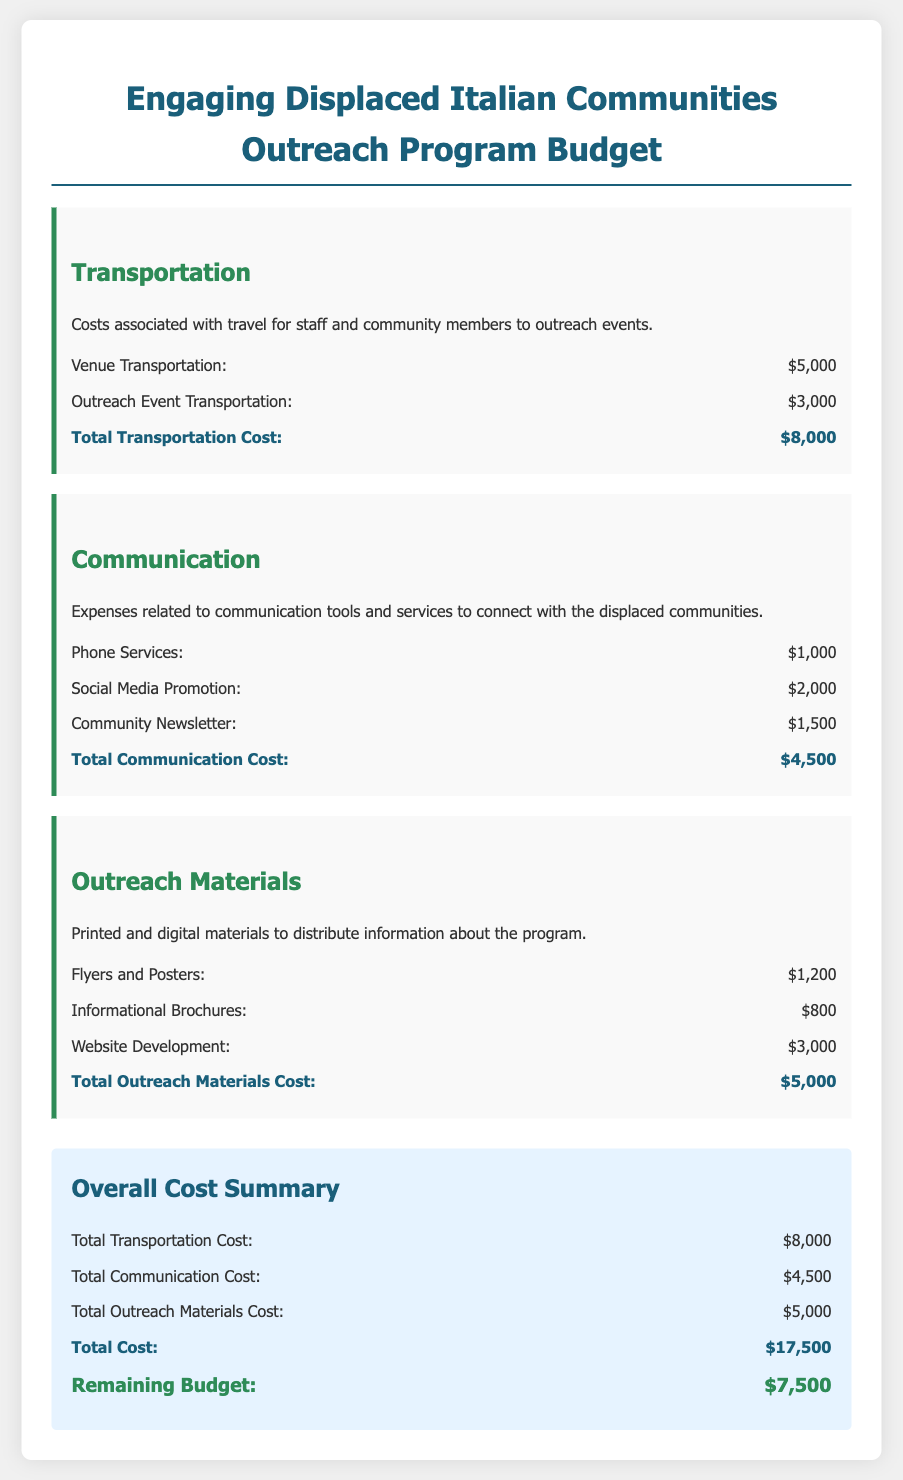What is the total transportation cost? The total transportation cost is the sum of venue transportation and outreach event transportation, which is $5,000 + $3,000 = $8,000.
Answer: $8,000 What is the total communication cost? The total communication cost is the sum of phone services, social media promotion, and community newsletter, which is $1,000 + $2,000 + $1,500 = $4,500.
Answer: $4,500 What is the total outreach materials cost? The total outreach materials cost is the sum of flyers and posters, informational brochures, and website development, which is $1,200 + $800 + $3,000 = $5,000.
Answer: $5,000 What is the total cost of the program? The total cost of the program is the sum of transportation, communication, and outreach materials costs, which is $8,000 + $4,500 + $5,000 = $17,500.
Answer: $17,500 What is the remaining budget? The remaining budget is stated as $7,500 in the overall cost summary section.
Answer: $7,500 How much is allocated for social media promotion? Social media promotion is listed as an expense under communication with a cost of $2,000.
Answer: $2,000 What are the expenses related to outreach materials? The expenses for outreach materials include flyers, brochures, and website development with totals of $1,200, $800, and $3,000 respectively.
Answer: $1,200, $800, $3,000 What is the purpose of the communication expenses? The communication expenses are specifically for tools and services to connect with the displaced communities.
Answer: Connecting with the displaced communities What is included in the transportation category? The transportation category includes venue transportation and outreach event transportation costs.
Answer: Venue and outreach event transportation 